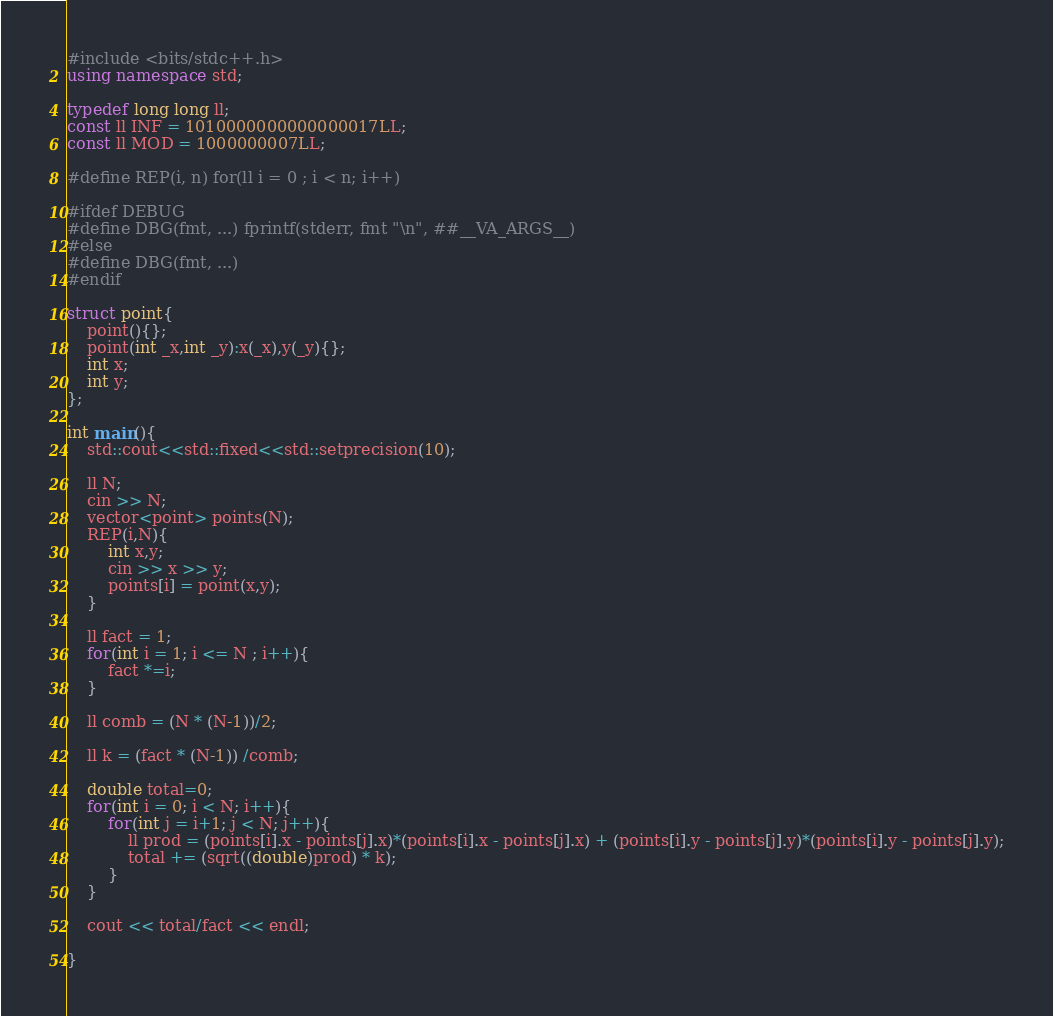Convert code to text. <code><loc_0><loc_0><loc_500><loc_500><_C++_>#include <bits/stdc++.h>
using namespace std;

typedef long long ll;
const ll INF = 1010000000000000017LL;
const ll MOD = 1000000007LL;

#define REP(i, n) for(ll i = 0 ; i < n; i++)

#ifdef DEBUG
#define DBG(fmt, ...) fprintf(stderr, fmt "\n", ##__VA_ARGS__)
#else
#define DBG(fmt, ...)
#endif

struct point{
    point(){};
    point(int _x,int _y):x(_x),y(_y){};
    int x;
    int y;
};

int main(){
    std::cout<<std::fixed<<std::setprecision(10);

    ll N;
    cin >> N;
    vector<point> points(N);
    REP(i,N){
        int x,y;
        cin >> x >> y;
        points[i] = point(x,y);
    }

    ll fact = 1;
    for(int i = 1; i <= N ; i++){
        fact *=i;
    }

    ll comb = (N * (N-1))/2;

    ll k = (fact * (N-1)) /comb;

    double total=0;
    for(int i = 0; i < N; i++){
        for(int j = i+1; j < N; j++){
            ll prod = (points[i].x - points[j].x)*(points[i].x - points[j].x) + (points[i].y - points[j].y)*(points[i].y - points[j].y);
            total += (sqrt((double)prod) * k);
        }
    }

    cout << total/fact << endl;

}
</code> 